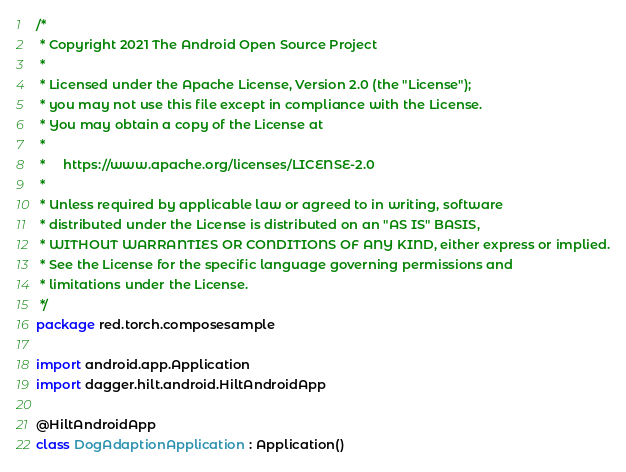<code> <loc_0><loc_0><loc_500><loc_500><_Kotlin_>/*
 * Copyright 2021 The Android Open Source Project
 *
 * Licensed under the Apache License, Version 2.0 (the "License");
 * you may not use this file except in compliance with the License.
 * You may obtain a copy of the License at
 *
 *     https://www.apache.org/licenses/LICENSE-2.0
 *
 * Unless required by applicable law or agreed to in writing, software
 * distributed under the License is distributed on an "AS IS" BASIS,
 * WITHOUT WARRANTIES OR CONDITIONS OF ANY KIND, either express or implied.
 * See the License for the specific language governing permissions and
 * limitations under the License.
 */
package red.torch.composesample

import android.app.Application
import dagger.hilt.android.HiltAndroidApp

@HiltAndroidApp
class DogAdaptionApplication : Application()
</code> 